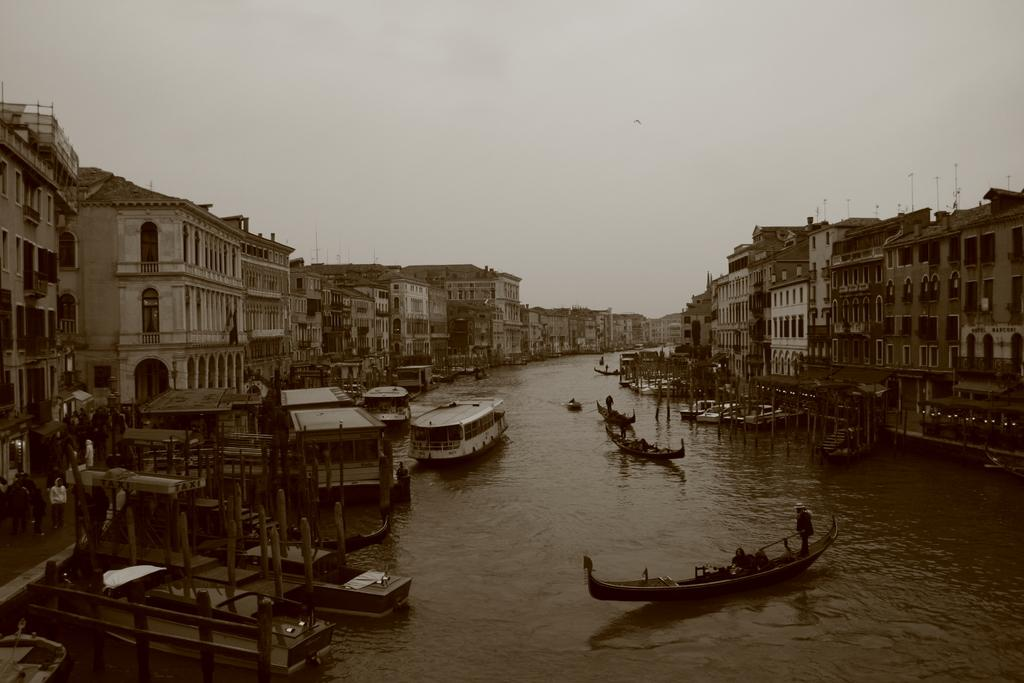What type of natural feature is present in the image? There is a river in the image. What is happening on the river? There are many boats on the river. What can be seen around the river? There are a lot of buildings around the river. What type of skin condition can be seen on the boats in the image? There is no mention of any skin condition in the image, as the boats are inanimate objects. 